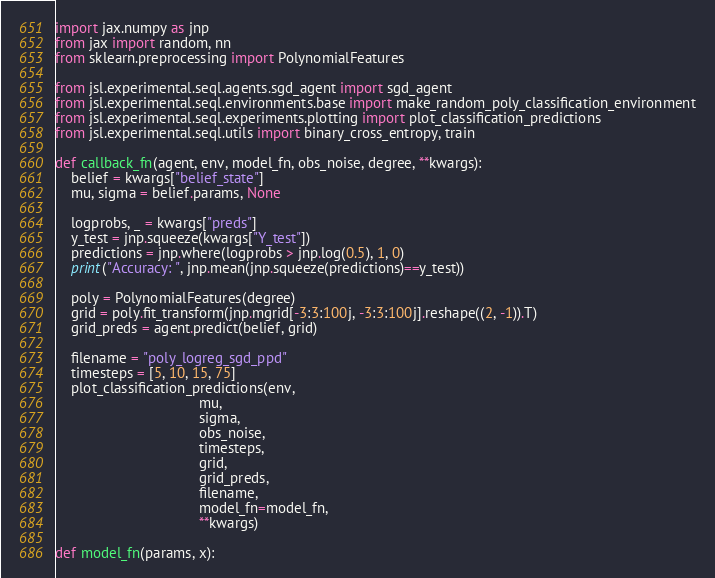<code> <loc_0><loc_0><loc_500><loc_500><_Python_>import jax.numpy as jnp
from jax import random, nn
from sklearn.preprocessing import PolynomialFeatures

from jsl.experimental.seql.agents.sgd_agent import sgd_agent
from jsl.experimental.seql.environments.base import make_random_poly_classification_environment
from jsl.experimental.seql.experiments.plotting import plot_classification_predictions
from jsl.experimental.seql.utils import binary_cross_entropy, train

def callback_fn(agent, env, model_fn, obs_noise, degree, **kwargs):
    belief = kwargs["belief_state"]
    mu, sigma = belief.params, None

    logprobs, _ = kwargs["preds"]
    y_test = jnp.squeeze(kwargs["Y_test"])
    predictions = jnp.where(logprobs > jnp.log(0.5), 1, 0)
    print("Accuracy: ", jnp.mean(jnp.squeeze(predictions)==y_test))

    poly = PolynomialFeatures(degree)
    grid = poly.fit_transform(jnp.mgrid[-3:3:100j, -3:3:100j].reshape((2, -1)).T)
    grid_preds = agent.predict(belief, grid)

    filename = "poly_logreg_sgd_ppd"
    timesteps = [5, 10, 15, 75]
    plot_classification_predictions(env,
                                    mu,
                                    sigma,
                                    obs_noise,
                                    timesteps,
                                    grid,
                                    grid_preds,
                                    filename,
                                    model_fn=model_fn,
                                    **kwargs)

def model_fn(params, x):</code> 